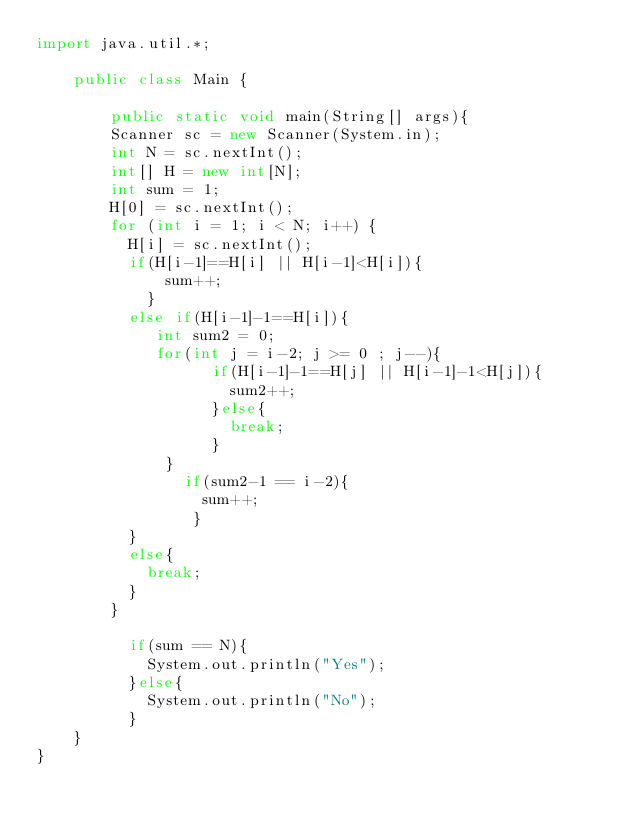Convert code to text. <code><loc_0><loc_0><loc_500><loc_500><_Java_>import java.util.*;

	public class Main {

		public static void main(String[] args){
		Scanner sc = new Scanner(System.in);
		int N = sc.nextInt();
        int[] H = new int[N];
        int sum = 1;
        H[0] = sc.nextInt();
        for (int i = 1; i < N; i++) {
		  H[i] = sc.nextInt();
          if(H[i-1]==H[i] || H[i-1]<H[i]){
              sum++;
            }
          else if(H[i-1]-1==H[i]){
             int sum2 = 0;
           	 for(int j = i-2; j >= 0 ; j--){
            	   if(H[i-1]-1==H[j] || H[i-1]-1<H[j]){
            	     sum2++;
            	   }else{
                     break;
                   }
          	  }
             	if(sum2-1 == i-2){
             	  sum++;
            	 }
          }
          else{
            break;
          }
        }
          
          if(sum == N){
            System.out.println("Yes");
          }else{
            System.out.println("No");
          }       
	}
}</code> 